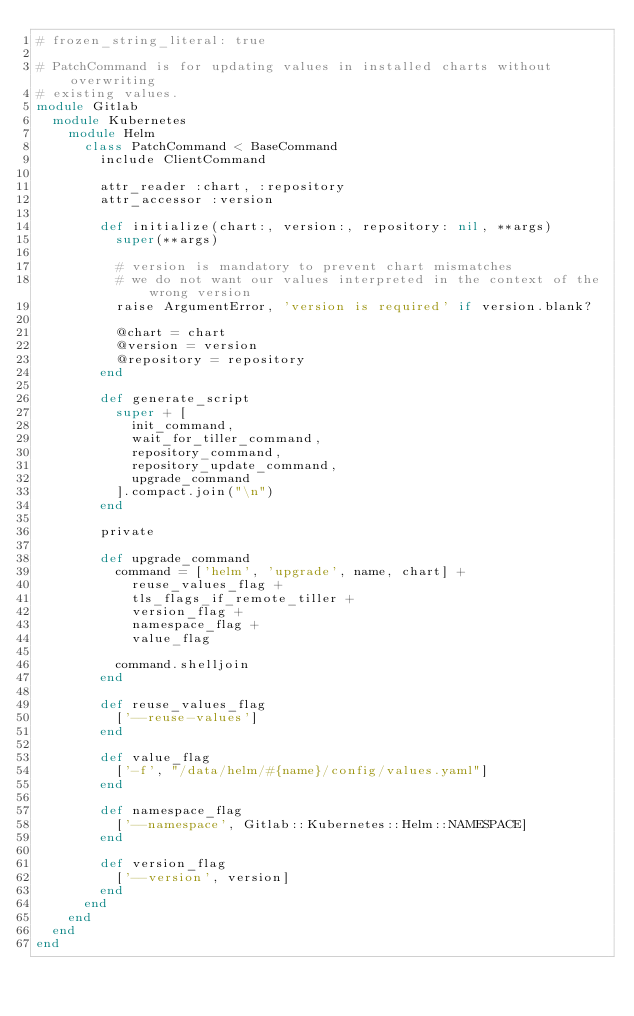Convert code to text. <code><loc_0><loc_0><loc_500><loc_500><_Ruby_># frozen_string_literal: true

# PatchCommand is for updating values in installed charts without overwriting
# existing values.
module Gitlab
  module Kubernetes
    module Helm
      class PatchCommand < BaseCommand
        include ClientCommand

        attr_reader :chart, :repository
        attr_accessor :version

        def initialize(chart:, version:, repository: nil, **args)
          super(**args)

          # version is mandatory to prevent chart mismatches
          # we do not want our values interpreted in the context of the wrong version
          raise ArgumentError, 'version is required' if version.blank?

          @chart = chart
          @version = version
          @repository = repository
        end

        def generate_script
          super + [
            init_command,
            wait_for_tiller_command,
            repository_command,
            repository_update_command,
            upgrade_command
          ].compact.join("\n")
        end

        private

        def upgrade_command
          command = ['helm', 'upgrade', name, chart] +
            reuse_values_flag +
            tls_flags_if_remote_tiller +
            version_flag +
            namespace_flag +
            value_flag

          command.shelljoin
        end

        def reuse_values_flag
          ['--reuse-values']
        end

        def value_flag
          ['-f', "/data/helm/#{name}/config/values.yaml"]
        end

        def namespace_flag
          ['--namespace', Gitlab::Kubernetes::Helm::NAMESPACE]
        end

        def version_flag
          ['--version', version]
        end
      end
    end
  end
end
</code> 